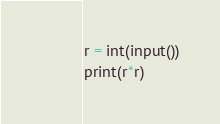Convert code to text. <code><loc_0><loc_0><loc_500><loc_500><_Python_>r = int(input())
print(r*r)</code> 